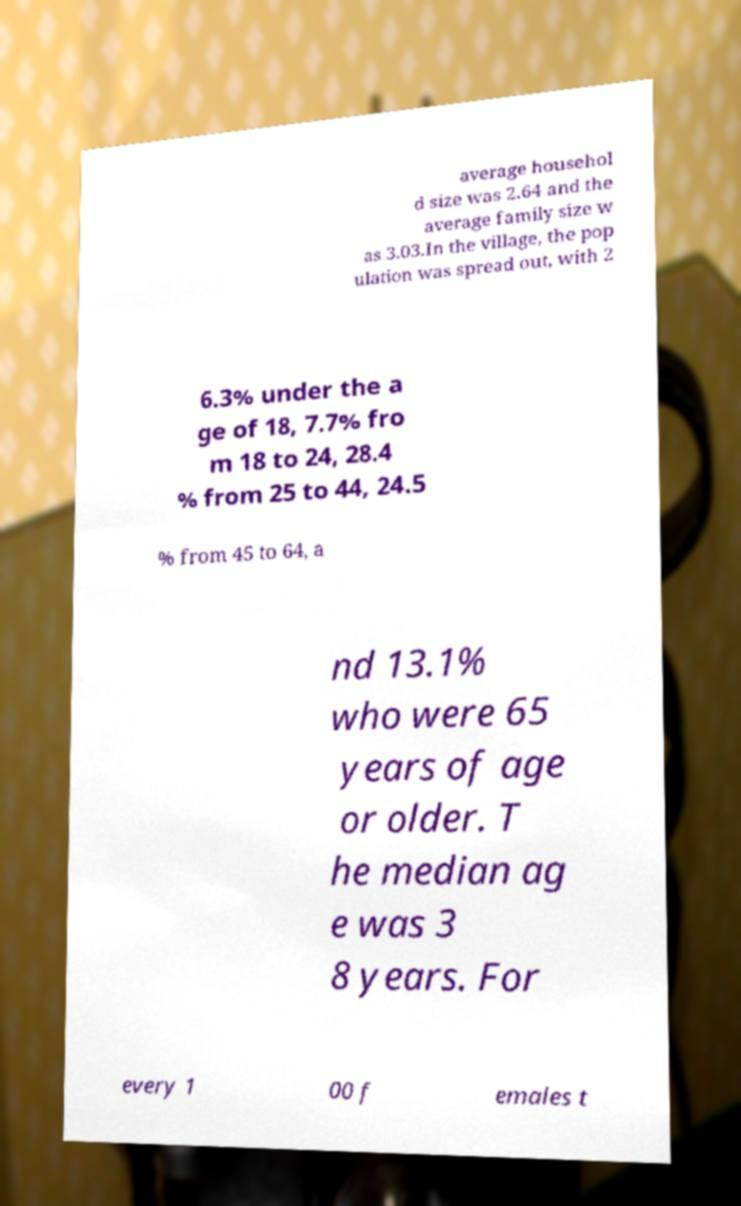Can you read and provide the text displayed in the image?This photo seems to have some interesting text. Can you extract and type it out for me? average househol d size was 2.64 and the average family size w as 3.03.In the village, the pop ulation was spread out, with 2 6.3% under the a ge of 18, 7.7% fro m 18 to 24, 28.4 % from 25 to 44, 24.5 % from 45 to 64, a nd 13.1% who were 65 years of age or older. T he median ag e was 3 8 years. For every 1 00 f emales t 